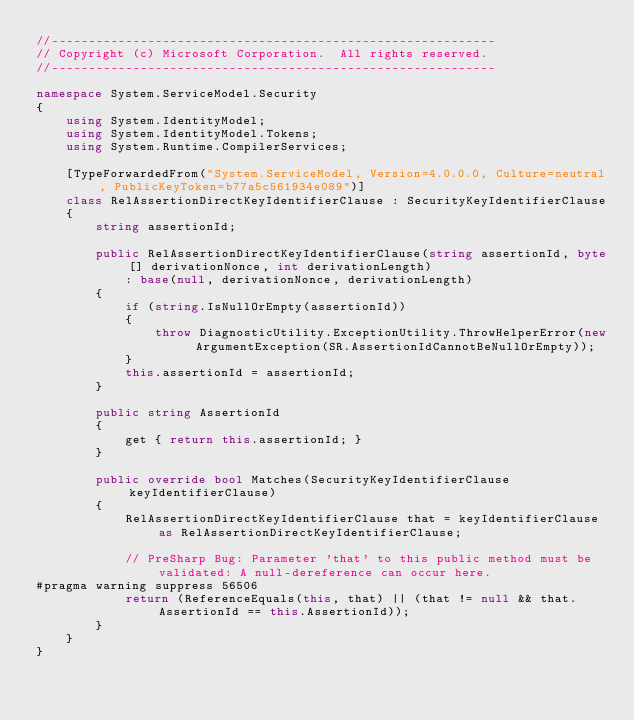Convert code to text. <code><loc_0><loc_0><loc_500><loc_500><_C#_>//------------------------------------------------------------
// Copyright (c) Microsoft Corporation.  All rights reserved.
//------------------------------------------------------------

namespace System.ServiceModel.Security
{
    using System.IdentityModel;
    using System.IdentityModel.Tokens;
    using System.Runtime.CompilerServices;

    [TypeForwardedFrom("System.ServiceModel, Version=4.0.0.0, Culture=neutral, PublicKeyToken=b77a5c561934e089")]
    class RelAssertionDirectKeyIdentifierClause : SecurityKeyIdentifierClause
    {
        string assertionId;

        public RelAssertionDirectKeyIdentifierClause(string assertionId, byte[] derivationNonce, int derivationLength)
            : base(null, derivationNonce, derivationLength)
        {
            if (string.IsNullOrEmpty(assertionId))
            {
                throw DiagnosticUtility.ExceptionUtility.ThrowHelperError(new ArgumentException(SR.AssertionIdCannotBeNullOrEmpty));
            }
            this.assertionId = assertionId;
        }

        public string AssertionId
        {
            get { return this.assertionId; }
        }

        public override bool Matches(SecurityKeyIdentifierClause keyIdentifierClause)
        {
            RelAssertionDirectKeyIdentifierClause that = keyIdentifierClause as RelAssertionDirectKeyIdentifierClause;

            // PreSharp Bug: Parameter 'that' to this public method must be validated: A null-dereference can occur here.
#pragma warning suppress 56506
            return (ReferenceEquals(this, that) || (that != null && that.AssertionId == this.AssertionId));
        }
    }
}
</code> 